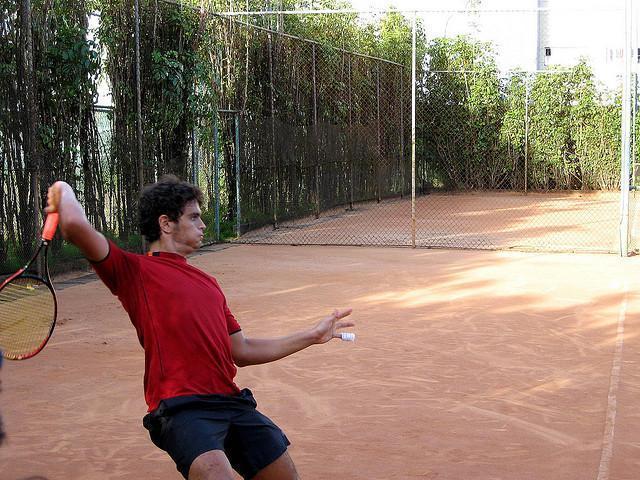How many grey bears are in the picture?
Give a very brief answer. 0. 